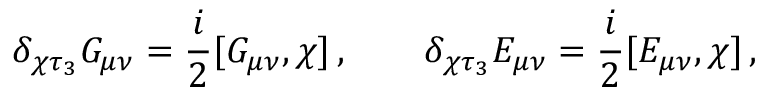<formula> <loc_0><loc_0><loc_500><loc_500>\delta _ { \chi \tau _ { 3 } } G _ { \mu \nu } = \frac { i } { 2 } [ G _ { \mu \nu } , \chi ] \, , \quad \delta _ { \chi \tau _ { 3 } } E _ { \mu \nu } = \frac { i } { 2 } [ E _ { \mu \nu } , \chi ] \, ,</formula> 